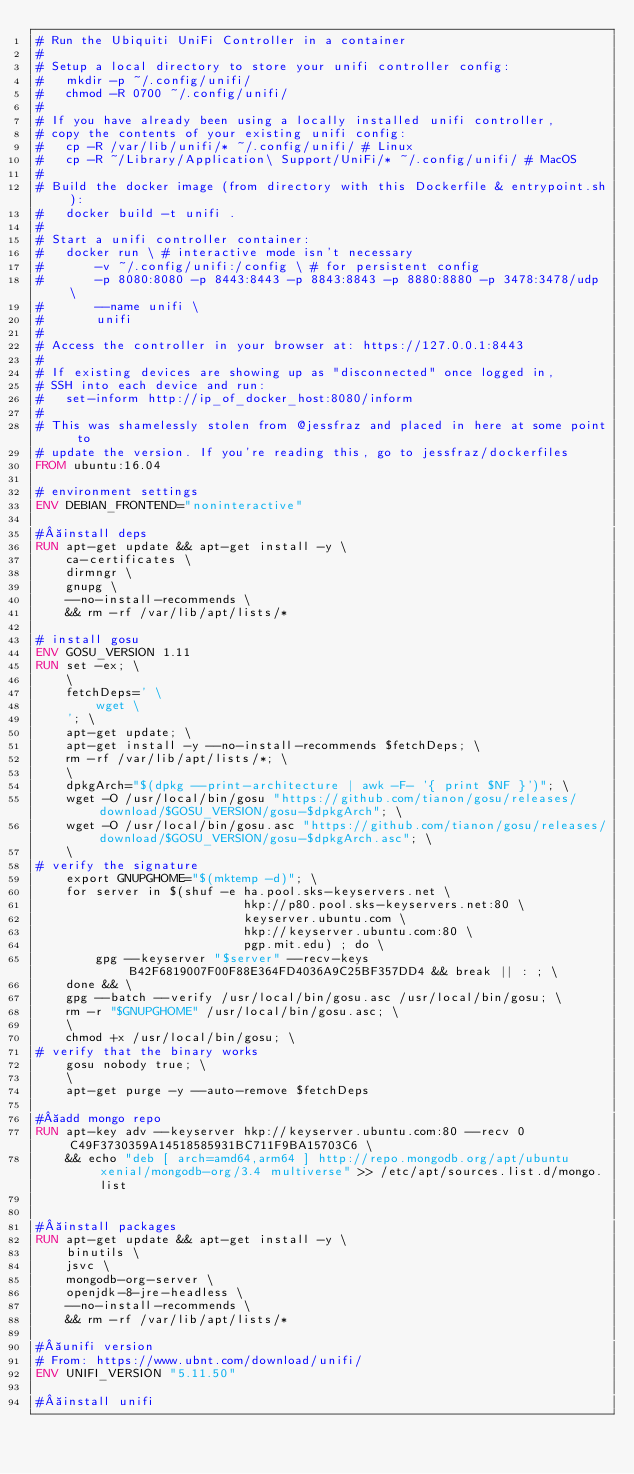Convert code to text. <code><loc_0><loc_0><loc_500><loc_500><_Dockerfile_># Run the Ubiquiti UniFi Controller in a container
#
# Setup a local directory to store your unifi controller config:
# 	mkdir -p ~/.config/unifi/
# 	chmod -R 0700 ~/.config/unifi/
#
# If you have already been using a locally installed unifi controller,
# copy the contents of your existing unifi config:
#	cp -R /var/lib/unifi/* ~/.config/unifi/	# Linux
#	cp -R ~/Library/Application\ Support/UniFi/* ~/.config/unifi/ # MacOS
#
# Build the docker image (from directory with this Dockerfile & entrypoint.sh):
#	docker build -t unifi .
#
# Start a unifi controller container:
#	docker run \ # interactive mode isn't necessary
#		-v ~/.config/unifi:/config \ # for persistent config
#		-p 8080:8080 -p 8443:8443 -p 8843:8843 -p 8880:8880 -p 3478:3478/udp \
#		--name unifi \
#		unifi
#
# Access the controller in your browser at: https://127.0.0.1:8443
#
# If existing devices are showing up as "disconnected" once logged in,
# SSH into each device and run:
# 	set-inform http://ip_of_docker_host:8080/inform
#
# This was shamelessly stolen from @jessfraz and placed in here at some point to
# update the version. If you're reading this, go to jessfraz/dockerfiles 
FROM ubuntu:16.04

# environment settings
ENV DEBIAN_FRONTEND="noninteractive"

# install deps
RUN apt-get update && apt-get install -y \
	ca-certificates \
	dirmngr \
	gnupg \
	--no-install-recommends \
	&& rm -rf /var/lib/apt/lists/*

# install gosu
ENV GOSU_VERSION 1.11
RUN set -ex; \
	\
	fetchDeps=' \
		wget \
	'; \
	apt-get update; \
	apt-get install -y --no-install-recommends $fetchDeps; \
	rm -rf /var/lib/apt/lists/*; \
	\
	dpkgArch="$(dpkg --print-architecture | awk -F- '{ print $NF }')"; \
	wget -O /usr/local/bin/gosu "https://github.com/tianon/gosu/releases/download/$GOSU_VERSION/gosu-$dpkgArch"; \
	wget -O /usr/local/bin/gosu.asc "https://github.com/tianon/gosu/releases/download/$GOSU_VERSION/gosu-$dpkgArch.asc"; \
	\
# verify the signature
	export GNUPGHOME="$(mktemp -d)"; \
    for server in $(shuf -e ha.pool.sks-keyservers.net \
                            hkp://p80.pool.sks-keyservers.net:80 \
                            keyserver.ubuntu.com \
                            hkp://keyserver.ubuntu.com:80 \
                            pgp.mit.edu) ; do \
        gpg --keyserver "$server" --recv-keys B42F6819007F00F88E364FD4036A9C25BF357DD4 && break || : ; \
    done && \
	gpg --batch --verify /usr/local/bin/gosu.asc /usr/local/bin/gosu; \
	rm -r "$GNUPGHOME" /usr/local/bin/gosu.asc; \
	\
	chmod +x /usr/local/bin/gosu; \
# verify that the binary works
	gosu nobody true; \
	\
	apt-get purge -y --auto-remove $fetchDeps

# add mongo repo
RUN apt-key adv --keyserver hkp://keyserver.ubuntu.com:80 --recv 0C49F3730359A14518585931BC711F9BA15703C6 \
	&& echo "deb [ arch=amd64,arm64 ] http://repo.mongodb.org/apt/ubuntu xenial/mongodb-org/3.4 multiverse" >> /etc/apt/sources.list.d/mongo.list


# install packages
RUN apt-get update && apt-get install -y \
	binutils \
	jsvc \
	mongodb-org-server \
	openjdk-8-jre-headless \
	--no-install-recommends \
	&& rm -rf /var/lib/apt/lists/*

# unifi version
# From: https://www.ubnt.com/download/unifi/
ENV UNIFI_VERSION "5.11.50"

# install unifi</code> 